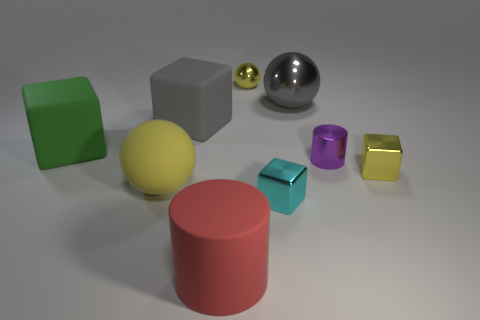Subtract all green cubes. How many cubes are left? 3 Subtract all cyan blocks. How many yellow spheres are left? 2 Add 1 blue spheres. How many objects exist? 10 Subtract all green blocks. How many blocks are left? 3 Subtract 1 blocks. How many blocks are left? 3 Subtract all cylinders. How many objects are left? 7 Subtract all gray cubes. Subtract all gray cylinders. How many cubes are left? 3 Subtract all yellow matte spheres. Subtract all yellow metallic spheres. How many objects are left? 7 Add 3 small yellow shiny blocks. How many small yellow shiny blocks are left? 4 Add 9 red blocks. How many red blocks exist? 9 